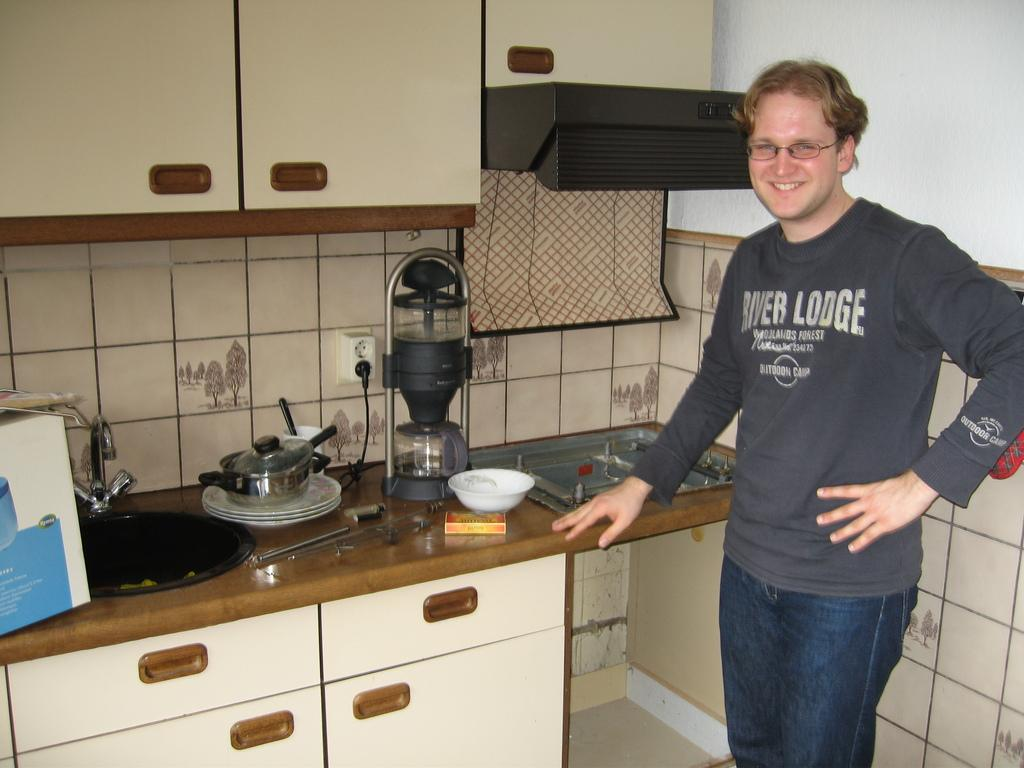Provide a one-sentence caption for the provided image. A man in the kitchen wearing a River Lodge shirt and smiling. 